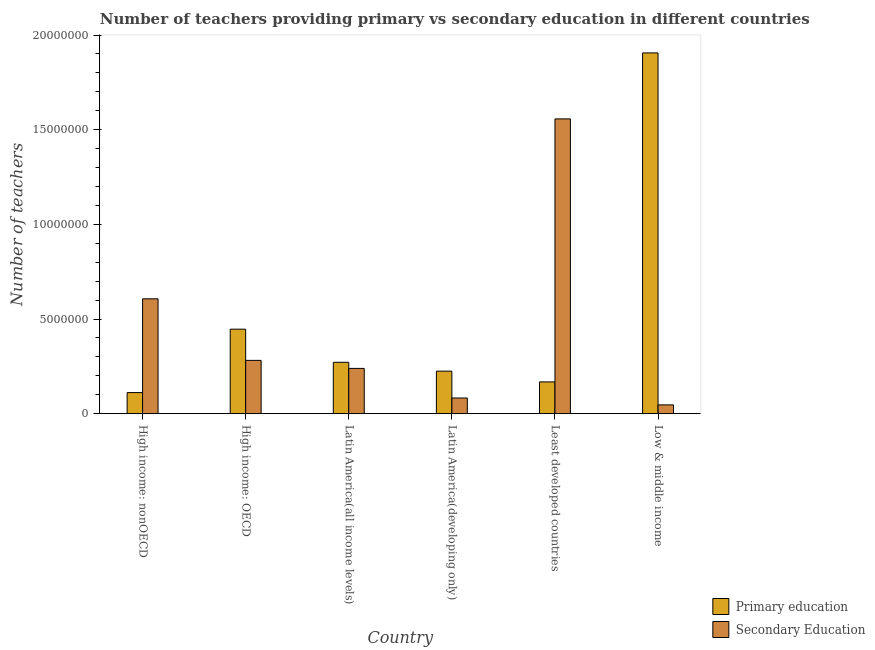How many groups of bars are there?
Your answer should be compact. 6. Are the number of bars per tick equal to the number of legend labels?
Ensure brevity in your answer.  Yes. How many bars are there on the 4th tick from the left?
Provide a short and direct response. 2. What is the label of the 1st group of bars from the left?
Offer a very short reply. High income: nonOECD. In how many cases, is the number of bars for a given country not equal to the number of legend labels?
Give a very brief answer. 0. What is the number of primary teachers in Least developed countries?
Your answer should be compact. 1.68e+06. Across all countries, what is the maximum number of primary teachers?
Your answer should be compact. 1.91e+07. Across all countries, what is the minimum number of secondary teachers?
Provide a short and direct response. 4.68e+05. In which country was the number of primary teachers maximum?
Make the answer very short. Low & middle income. In which country was the number of primary teachers minimum?
Offer a terse response. High income: nonOECD. What is the total number of primary teachers in the graph?
Ensure brevity in your answer.  3.13e+07. What is the difference between the number of primary teachers in High income: nonOECD and that in Least developed countries?
Keep it short and to the point. -5.64e+05. What is the difference between the number of primary teachers in High income: OECD and the number of secondary teachers in Least developed countries?
Provide a short and direct response. -1.11e+07. What is the average number of primary teachers per country?
Offer a terse response. 5.21e+06. What is the difference between the number of secondary teachers and number of primary teachers in Latin America(developing only)?
Ensure brevity in your answer.  -1.42e+06. What is the ratio of the number of primary teachers in High income: nonOECD to that in Latin America(all income levels)?
Your answer should be very brief. 0.41. Is the difference between the number of primary teachers in Least developed countries and Low & middle income greater than the difference between the number of secondary teachers in Least developed countries and Low & middle income?
Provide a succinct answer. No. What is the difference between the highest and the second highest number of secondary teachers?
Give a very brief answer. 9.50e+06. What is the difference between the highest and the lowest number of primary teachers?
Offer a terse response. 1.79e+07. In how many countries, is the number of secondary teachers greater than the average number of secondary teachers taken over all countries?
Provide a short and direct response. 2. Is the sum of the number of primary teachers in High income: OECD and Low & middle income greater than the maximum number of secondary teachers across all countries?
Offer a terse response. Yes. What does the 2nd bar from the left in Low & middle income represents?
Your answer should be very brief. Secondary Education. Are all the bars in the graph horizontal?
Provide a short and direct response. No. Does the graph contain any zero values?
Offer a terse response. No. Where does the legend appear in the graph?
Provide a short and direct response. Bottom right. How many legend labels are there?
Your answer should be very brief. 2. What is the title of the graph?
Offer a terse response. Number of teachers providing primary vs secondary education in different countries. Does "Death rate" appear as one of the legend labels in the graph?
Ensure brevity in your answer.  No. What is the label or title of the X-axis?
Offer a very short reply. Country. What is the label or title of the Y-axis?
Give a very brief answer. Number of teachers. What is the Number of teachers of Primary education in High income: nonOECD?
Your response must be concise. 1.12e+06. What is the Number of teachers in Secondary Education in High income: nonOECD?
Give a very brief answer. 6.07e+06. What is the Number of teachers in Primary education in High income: OECD?
Your response must be concise. 4.47e+06. What is the Number of teachers in Secondary Education in High income: OECD?
Provide a succinct answer. 2.82e+06. What is the Number of teachers of Primary education in Latin America(all income levels)?
Keep it short and to the point. 2.72e+06. What is the Number of teachers in Secondary Education in Latin America(all income levels)?
Ensure brevity in your answer.  2.39e+06. What is the Number of teachers in Primary education in Latin America(developing only)?
Keep it short and to the point. 2.25e+06. What is the Number of teachers in Secondary Education in Latin America(developing only)?
Your answer should be compact. 8.32e+05. What is the Number of teachers in Primary education in Least developed countries?
Provide a succinct answer. 1.68e+06. What is the Number of teachers in Secondary Education in Least developed countries?
Give a very brief answer. 1.56e+07. What is the Number of teachers of Primary education in Low & middle income?
Your response must be concise. 1.91e+07. What is the Number of teachers in Secondary Education in Low & middle income?
Make the answer very short. 4.68e+05. Across all countries, what is the maximum Number of teachers of Primary education?
Offer a terse response. 1.91e+07. Across all countries, what is the maximum Number of teachers in Secondary Education?
Ensure brevity in your answer.  1.56e+07. Across all countries, what is the minimum Number of teachers of Primary education?
Your answer should be compact. 1.12e+06. Across all countries, what is the minimum Number of teachers of Secondary Education?
Your answer should be very brief. 4.68e+05. What is the total Number of teachers in Primary education in the graph?
Provide a short and direct response. 3.13e+07. What is the total Number of teachers of Secondary Education in the graph?
Your answer should be compact. 2.82e+07. What is the difference between the Number of teachers in Primary education in High income: nonOECD and that in High income: OECD?
Offer a very short reply. -3.35e+06. What is the difference between the Number of teachers in Secondary Education in High income: nonOECD and that in High income: OECD?
Offer a terse response. 3.25e+06. What is the difference between the Number of teachers in Primary education in High income: nonOECD and that in Latin America(all income levels)?
Give a very brief answer. -1.60e+06. What is the difference between the Number of teachers of Secondary Education in High income: nonOECD and that in Latin America(all income levels)?
Your response must be concise. 3.67e+06. What is the difference between the Number of teachers in Primary education in High income: nonOECD and that in Latin America(developing only)?
Provide a succinct answer. -1.13e+06. What is the difference between the Number of teachers in Secondary Education in High income: nonOECD and that in Latin America(developing only)?
Your response must be concise. 5.24e+06. What is the difference between the Number of teachers of Primary education in High income: nonOECD and that in Least developed countries?
Ensure brevity in your answer.  -5.64e+05. What is the difference between the Number of teachers of Secondary Education in High income: nonOECD and that in Least developed countries?
Offer a terse response. -9.50e+06. What is the difference between the Number of teachers of Primary education in High income: nonOECD and that in Low & middle income?
Provide a short and direct response. -1.79e+07. What is the difference between the Number of teachers of Secondary Education in High income: nonOECD and that in Low & middle income?
Your answer should be very brief. 5.60e+06. What is the difference between the Number of teachers of Primary education in High income: OECD and that in Latin America(all income levels)?
Your response must be concise. 1.75e+06. What is the difference between the Number of teachers in Secondary Education in High income: OECD and that in Latin America(all income levels)?
Offer a terse response. 4.24e+05. What is the difference between the Number of teachers in Primary education in High income: OECD and that in Latin America(developing only)?
Your response must be concise. 2.22e+06. What is the difference between the Number of teachers in Secondary Education in High income: OECD and that in Latin America(developing only)?
Ensure brevity in your answer.  1.99e+06. What is the difference between the Number of teachers of Primary education in High income: OECD and that in Least developed countries?
Provide a succinct answer. 2.78e+06. What is the difference between the Number of teachers of Secondary Education in High income: OECD and that in Least developed countries?
Keep it short and to the point. -1.28e+07. What is the difference between the Number of teachers in Primary education in High income: OECD and that in Low & middle income?
Keep it short and to the point. -1.46e+07. What is the difference between the Number of teachers in Secondary Education in High income: OECD and that in Low & middle income?
Ensure brevity in your answer.  2.35e+06. What is the difference between the Number of teachers in Primary education in Latin America(all income levels) and that in Latin America(developing only)?
Keep it short and to the point. 4.68e+05. What is the difference between the Number of teachers in Secondary Education in Latin America(all income levels) and that in Latin America(developing only)?
Provide a short and direct response. 1.56e+06. What is the difference between the Number of teachers of Primary education in Latin America(all income levels) and that in Least developed countries?
Give a very brief answer. 1.04e+06. What is the difference between the Number of teachers of Secondary Education in Latin America(all income levels) and that in Least developed countries?
Give a very brief answer. -1.32e+07. What is the difference between the Number of teachers of Primary education in Latin America(all income levels) and that in Low & middle income?
Provide a short and direct response. -1.63e+07. What is the difference between the Number of teachers in Secondary Education in Latin America(all income levels) and that in Low & middle income?
Your answer should be very brief. 1.93e+06. What is the difference between the Number of teachers of Primary education in Latin America(developing only) and that in Least developed countries?
Your answer should be very brief. 5.69e+05. What is the difference between the Number of teachers of Secondary Education in Latin America(developing only) and that in Least developed countries?
Your answer should be very brief. -1.47e+07. What is the difference between the Number of teachers of Primary education in Latin America(developing only) and that in Low & middle income?
Offer a very short reply. -1.68e+07. What is the difference between the Number of teachers of Secondary Education in Latin America(developing only) and that in Low & middle income?
Offer a terse response. 3.64e+05. What is the difference between the Number of teachers of Primary education in Least developed countries and that in Low & middle income?
Provide a short and direct response. -1.74e+07. What is the difference between the Number of teachers of Secondary Education in Least developed countries and that in Low & middle income?
Provide a short and direct response. 1.51e+07. What is the difference between the Number of teachers in Primary education in High income: nonOECD and the Number of teachers in Secondary Education in High income: OECD?
Keep it short and to the point. -1.70e+06. What is the difference between the Number of teachers of Primary education in High income: nonOECD and the Number of teachers of Secondary Education in Latin America(all income levels)?
Your response must be concise. -1.28e+06. What is the difference between the Number of teachers in Primary education in High income: nonOECD and the Number of teachers in Secondary Education in Latin America(developing only)?
Offer a very short reply. 2.85e+05. What is the difference between the Number of teachers in Primary education in High income: nonOECD and the Number of teachers in Secondary Education in Least developed countries?
Keep it short and to the point. -1.45e+07. What is the difference between the Number of teachers in Primary education in High income: nonOECD and the Number of teachers in Secondary Education in Low & middle income?
Your answer should be compact. 6.49e+05. What is the difference between the Number of teachers of Primary education in High income: OECD and the Number of teachers of Secondary Education in Latin America(all income levels)?
Your answer should be very brief. 2.07e+06. What is the difference between the Number of teachers of Primary education in High income: OECD and the Number of teachers of Secondary Education in Latin America(developing only)?
Give a very brief answer. 3.63e+06. What is the difference between the Number of teachers of Primary education in High income: OECD and the Number of teachers of Secondary Education in Least developed countries?
Provide a succinct answer. -1.11e+07. What is the difference between the Number of teachers in Primary education in High income: OECD and the Number of teachers in Secondary Education in Low & middle income?
Your answer should be very brief. 4.00e+06. What is the difference between the Number of teachers in Primary education in Latin America(all income levels) and the Number of teachers in Secondary Education in Latin America(developing only)?
Your answer should be compact. 1.89e+06. What is the difference between the Number of teachers in Primary education in Latin America(all income levels) and the Number of teachers in Secondary Education in Least developed countries?
Give a very brief answer. -1.29e+07. What is the difference between the Number of teachers of Primary education in Latin America(all income levels) and the Number of teachers of Secondary Education in Low & middle income?
Make the answer very short. 2.25e+06. What is the difference between the Number of teachers of Primary education in Latin America(developing only) and the Number of teachers of Secondary Education in Least developed countries?
Give a very brief answer. -1.33e+07. What is the difference between the Number of teachers of Primary education in Latin America(developing only) and the Number of teachers of Secondary Education in Low & middle income?
Your response must be concise. 1.78e+06. What is the difference between the Number of teachers in Primary education in Least developed countries and the Number of teachers in Secondary Education in Low & middle income?
Provide a short and direct response. 1.21e+06. What is the average Number of teachers of Primary education per country?
Your response must be concise. 5.21e+06. What is the average Number of teachers in Secondary Education per country?
Provide a short and direct response. 4.69e+06. What is the difference between the Number of teachers of Primary education and Number of teachers of Secondary Education in High income: nonOECD?
Provide a succinct answer. -4.95e+06. What is the difference between the Number of teachers in Primary education and Number of teachers in Secondary Education in High income: OECD?
Ensure brevity in your answer.  1.65e+06. What is the difference between the Number of teachers of Primary education and Number of teachers of Secondary Education in Latin America(all income levels)?
Offer a very short reply. 3.23e+05. What is the difference between the Number of teachers in Primary education and Number of teachers in Secondary Education in Latin America(developing only)?
Provide a short and direct response. 1.42e+06. What is the difference between the Number of teachers in Primary education and Number of teachers in Secondary Education in Least developed countries?
Provide a succinct answer. -1.39e+07. What is the difference between the Number of teachers of Primary education and Number of teachers of Secondary Education in Low & middle income?
Provide a short and direct response. 1.86e+07. What is the ratio of the Number of teachers of Primary education in High income: nonOECD to that in High income: OECD?
Give a very brief answer. 0.25. What is the ratio of the Number of teachers of Secondary Education in High income: nonOECD to that in High income: OECD?
Offer a terse response. 2.15. What is the ratio of the Number of teachers in Primary education in High income: nonOECD to that in Latin America(all income levels)?
Your answer should be very brief. 0.41. What is the ratio of the Number of teachers in Secondary Education in High income: nonOECD to that in Latin America(all income levels)?
Give a very brief answer. 2.54. What is the ratio of the Number of teachers in Primary education in High income: nonOECD to that in Latin America(developing only)?
Your answer should be very brief. 0.5. What is the ratio of the Number of teachers in Secondary Education in High income: nonOECD to that in Latin America(developing only)?
Your response must be concise. 7.3. What is the ratio of the Number of teachers of Primary education in High income: nonOECD to that in Least developed countries?
Your answer should be compact. 0.66. What is the ratio of the Number of teachers in Secondary Education in High income: nonOECD to that in Least developed countries?
Give a very brief answer. 0.39. What is the ratio of the Number of teachers in Primary education in High income: nonOECD to that in Low & middle income?
Provide a succinct answer. 0.06. What is the ratio of the Number of teachers of Secondary Education in High income: nonOECD to that in Low & middle income?
Your response must be concise. 12.97. What is the ratio of the Number of teachers in Primary education in High income: OECD to that in Latin America(all income levels)?
Your answer should be compact. 1.64. What is the ratio of the Number of teachers of Secondary Education in High income: OECD to that in Latin America(all income levels)?
Keep it short and to the point. 1.18. What is the ratio of the Number of teachers of Primary education in High income: OECD to that in Latin America(developing only)?
Your response must be concise. 1.99. What is the ratio of the Number of teachers in Secondary Education in High income: OECD to that in Latin America(developing only)?
Give a very brief answer. 3.39. What is the ratio of the Number of teachers in Primary education in High income: OECD to that in Least developed countries?
Your answer should be very brief. 2.66. What is the ratio of the Number of teachers of Secondary Education in High income: OECD to that in Least developed countries?
Your response must be concise. 0.18. What is the ratio of the Number of teachers in Primary education in High income: OECD to that in Low & middle income?
Keep it short and to the point. 0.23. What is the ratio of the Number of teachers in Secondary Education in High income: OECD to that in Low & middle income?
Provide a succinct answer. 6.02. What is the ratio of the Number of teachers of Primary education in Latin America(all income levels) to that in Latin America(developing only)?
Offer a very short reply. 1.21. What is the ratio of the Number of teachers in Secondary Education in Latin America(all income levels) to that in Latin America(developing only)?
Give a very brief answer. 2.88. What is the ratio of the Number of teachers in Primary education in Latin America(all income levels) to that in Least developed countries?
Make the answer very short. 1.62. What is the ratio of the Number of teachers of Secondary Education in Latin America(all income levels) to that in Least developed countries?
Offer a terse response. 0.15. What is the ratio of the Number of teachers in Primary education in Latin America(all income levels) to that in Low & middle income?
Your response must be concise. 0.14. What is the ratio of the Number of teachers of Secondary Education in Latin America(all income levels) to that in Low & middle income?
Your response must be concise. 5.12. What is the ratio of the Number of teachers of Primary education in Latin America(developing only) to that in Least developed countries?
Provide a short and direct response. 1.34. What is the ratio of the Number of teachers in Secondary Education in Latin America(developing only) to that in Least developed countries?
Make the answer very short. 0.05. What is the ratio of the Number of teachers of Primary education in Latin America(developing only) to that in Low & middle income?
Your answer should be very brief. 0.12. What is the ratio of the Number of teachers in Secondary Education in Latin America(developing only) to that in Low & middle income?
Ensure brevity in your answer.  1.78. What is the ratio of the Number of teachers of Primary education in Least developed countries to that in Low & middle income?
Offer a very short reply. 0.09. What is the ratio of the Number of teachers in Secondary Education in Least developed countries to that in Low & middle income?
Provide a short and direct response. 33.28. What is the difference between the highest and the second highest Number of teachers in Primary education?
Your answer should be very brief. 1.46e+07. What is the difference between the highest and the second highest Number of teachers in Secondary Education?
Ensure brevity in your answer.  9.50e+06. What is the difference between the highest and the lowest Number of teachers of Primary education?
Make the answer very short. 1.79e+07. What is the difference between the highest and the lowest Number of teachers in Secondary Education?
Give a very brief answer. 1.51e+07. 